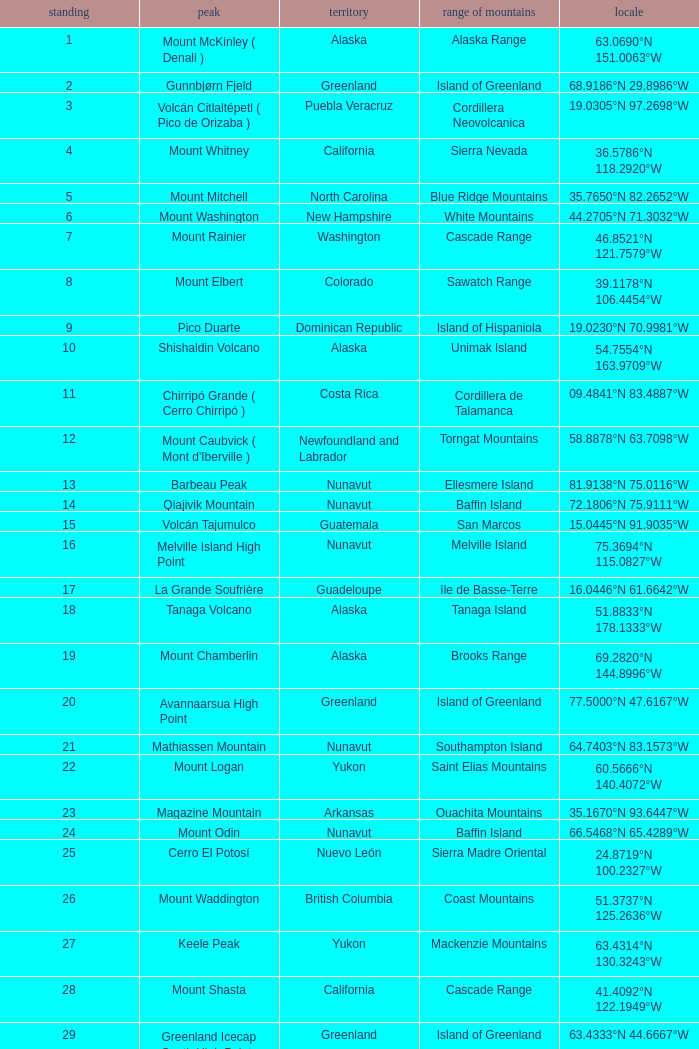Name the Region with a Mountain Peak of dillingham high point? Alaska. 